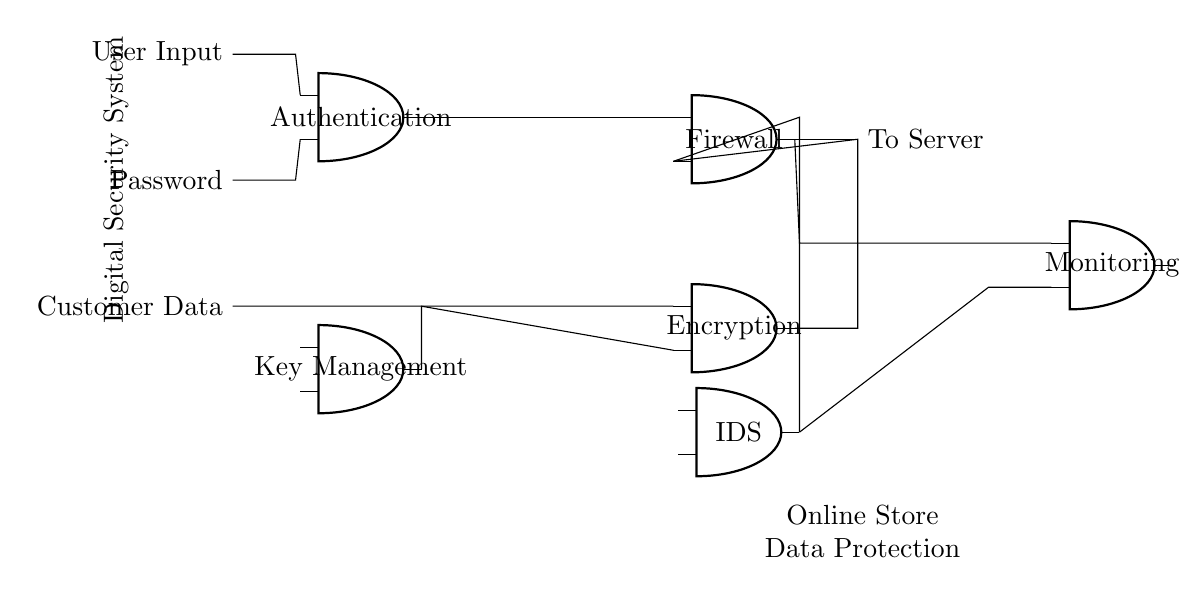What is the primary function of the firewall in the circuit? The firewall acts as a barrier that controls the incoming and outgoing network traffic, blocking unauthorized access while allowing legitimate traffic to pass.
Answer: Barrier for network traffic What type of data does the encryption module process? The encryption module processes customer data, ensuring that the information is securely encoded to prevent unauthorized access.
Answer: Customer data What component manages the encryption keys? The key management component is responsible for managing and distributing the encryption keys used by the encryption module to secure data.
Answer: Key management How many user input connections are present in the authentication module? There are two user input connections in the authentication module: one for general user input and one for the password, indicating that it requires both for validation.
Answer: Two connections What is the role of the intrusion detection system in this configuration? The intrusion detection system (IDS) monitors the network for suspicious activity and alerts when potential intrusions occur, enhancing overall security.
Answer: Monitor for suspicious activity Which components are connected to the monitoring system? The monitoring system is connected back to the firewall and the intrusion detection system, suggesting that it oversees traffic and alerts for any irregularities in access.
Answer: Firewall and IDS What is the relationship between the authentication module and the firewall? The authentication module feeds valid user input and password data directly into the firewall, suggesting it is the first line of defense in verifying user identities before allowing access.
Answer: Authentication verifies before firewall access 